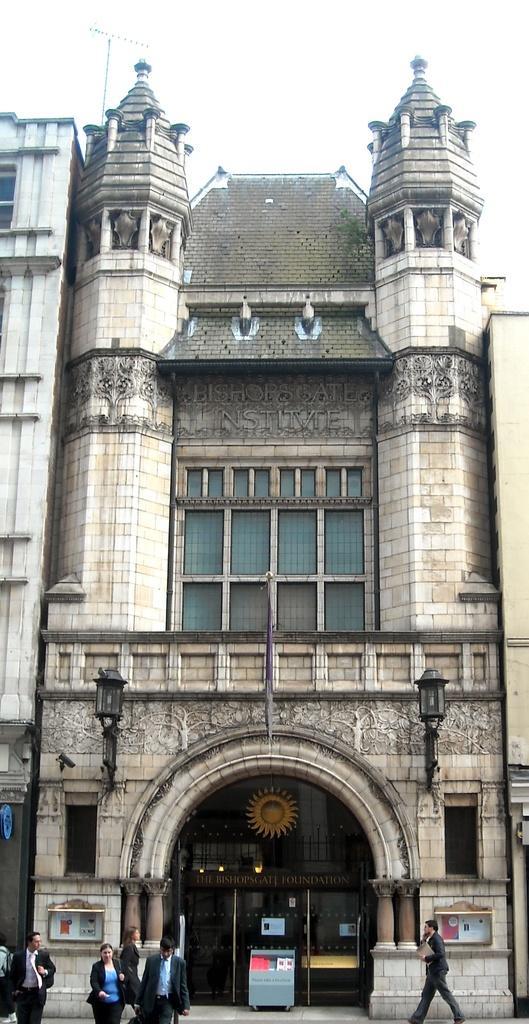Please provide a concise description of this image. In the center of the image there is a building. At the bottom of the image there are people walking. At the top of the image there is sky. 